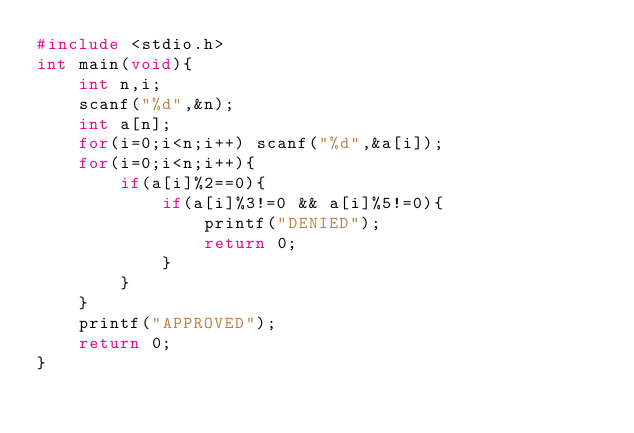<code> <loc_0><loc_0><loc_500><loc_500><_C_>#include <stdio.h>
int main(void){
    int n,i;
    scanf("%d",&n);
    int a[n];
    for(i=0;i<n;i++) scanf("%d",&a[i]);
    for(i=0;i<n;i++){
        if(a[i]%2==0){
            if(a[i]%3!=0 && a[i]%5!=0){
                printf("DENIED");
                return 0;
            }
        }
    }
    printf("APPROVED");
    return 0;
}
</code> 